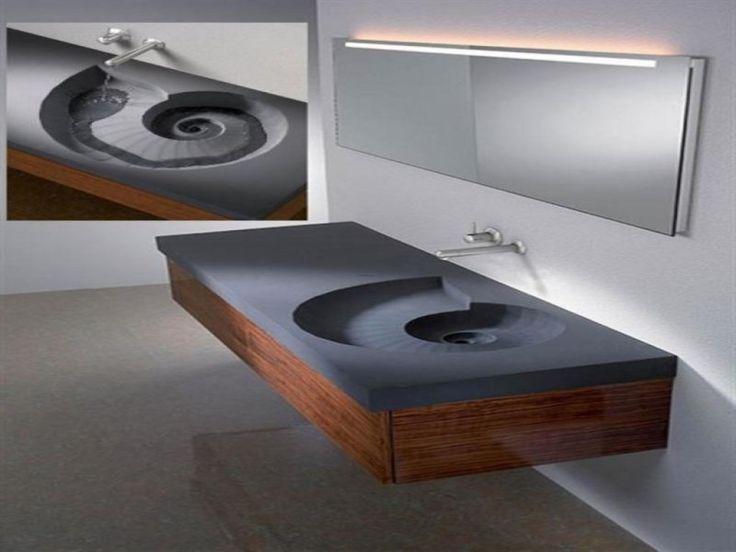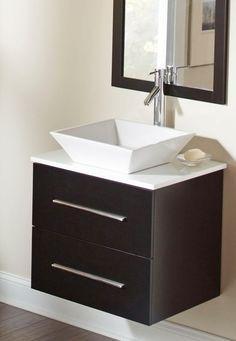The first image is the image on the left, the second image is the image on the right. Analyze the images presented: Is the assertion "Both image show a sink and vanity, but only one image has a rectangular sink basin." valid? Answer yes or no. Yes. The first image is the image on the left, the second image is the image on the right. Given the left and right images, does the statement "One of the sinks has no drawers attached to it." hold true? Answer yes or no. Yes. 